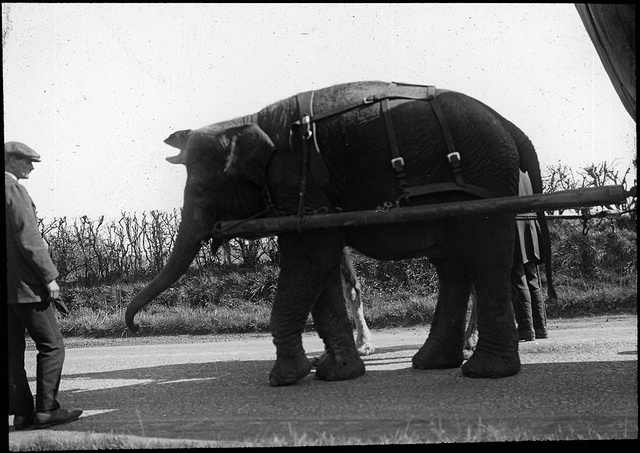Describe the objects in this image and their specific colors. I can see elephant in black, gray, darkgray, and lightgray tones, people in black, gray, darkgray, and lightgray tones, and people in black, gray, and lightgray tones in this image. 